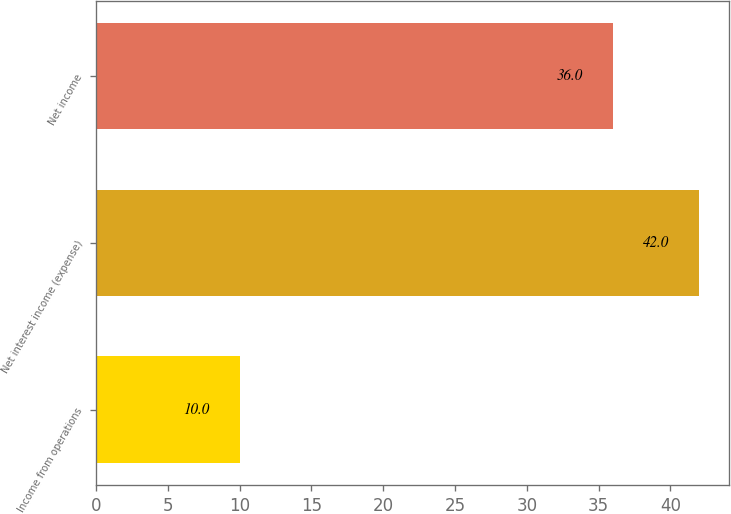Convert chart. <chart><loc_0><loc_0><loc_500><loc_500><bar_chart><fcel>Income from operations<fcel>Net interest income (expense)<fcel>Net income<nl><fcel>10<fcel>42<fcel>36<nl></chart> 